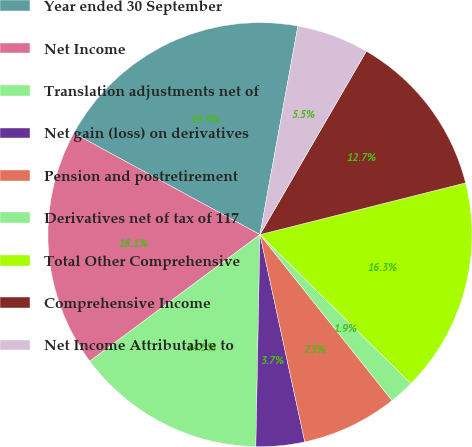Convert chart. <chart><loc_0><loc_0><loc_500><loc_500><pie_chart><fcel>Year ended 30 September<fcel>Net Income<fcel>Translation adjustments net of<fcel>Net gain (loss) on derivatives<fcel>Pension and postretirement<fcel>Derivatives net of tax of 117<fcel>Total Other Comprehensive<fcel>Comprehensive Income<fcel>Net Income Attributable to<nl><fcel>19.92%<fcel>18.12%<fcel>14.51%<fcel>3.7%<fcel>7.31%<fcel>1.9%<fcel>16.32%<fcel>12.71%<fcel>5.5%<nl></chart> 